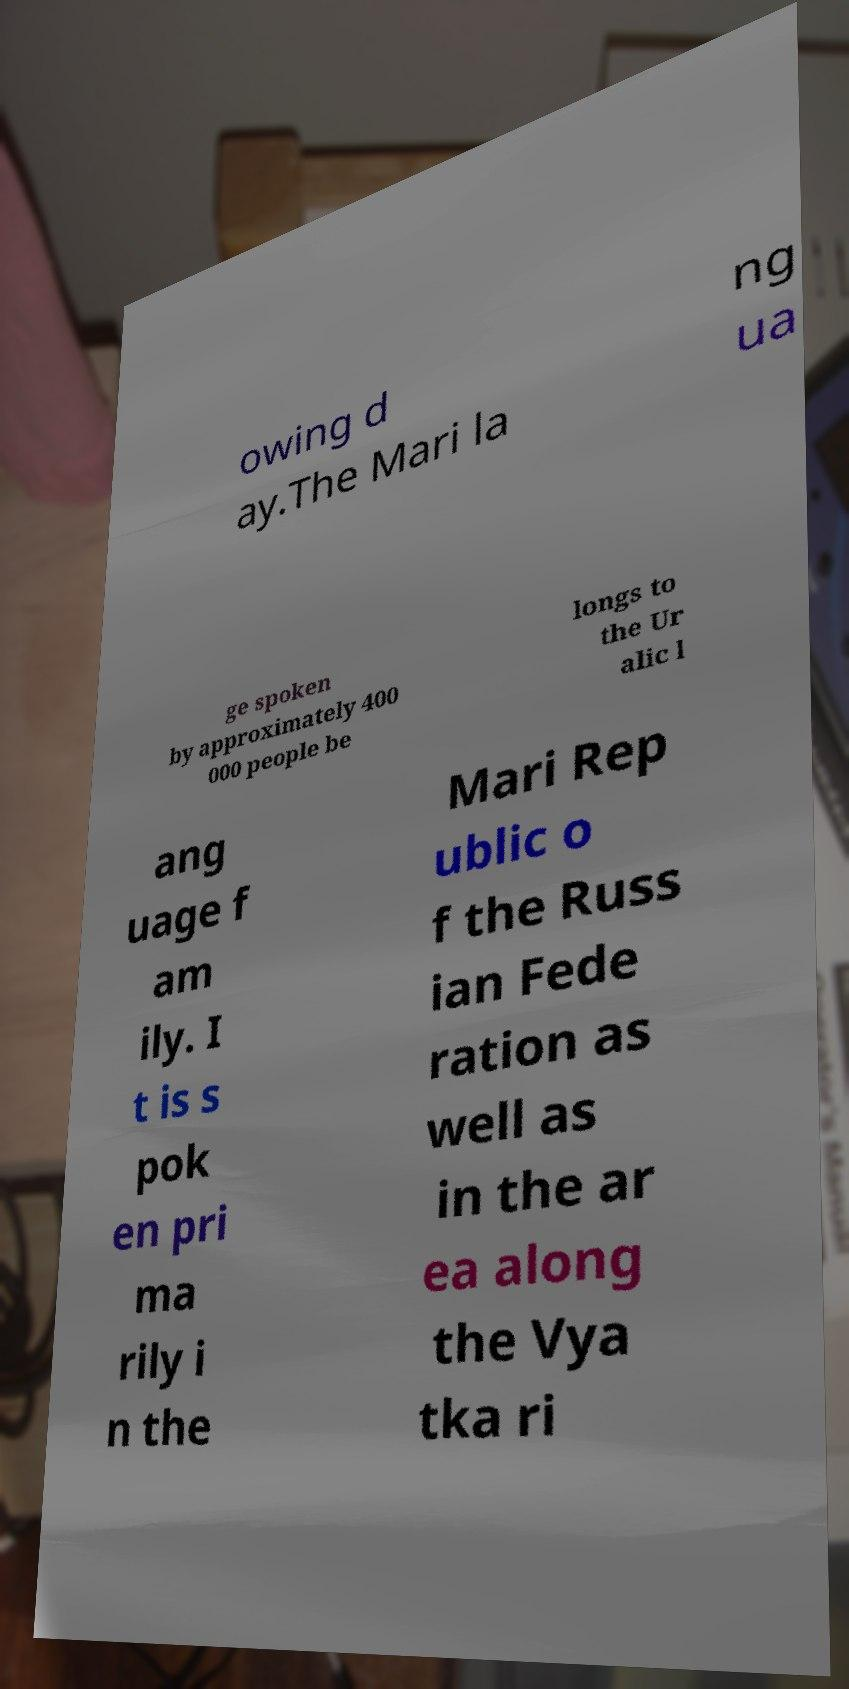Could you extract and type out the text from this image? owing d ay.The Mari la ng ua ge spoken by approximately 400 000 people be longs to the Ur alic l ang uage f am ily. I t is s pok en pri ma rily i n the Mari Rep ublic o f the Russ ian Fede ration as well as in the ar ea along the Vya tka ri 